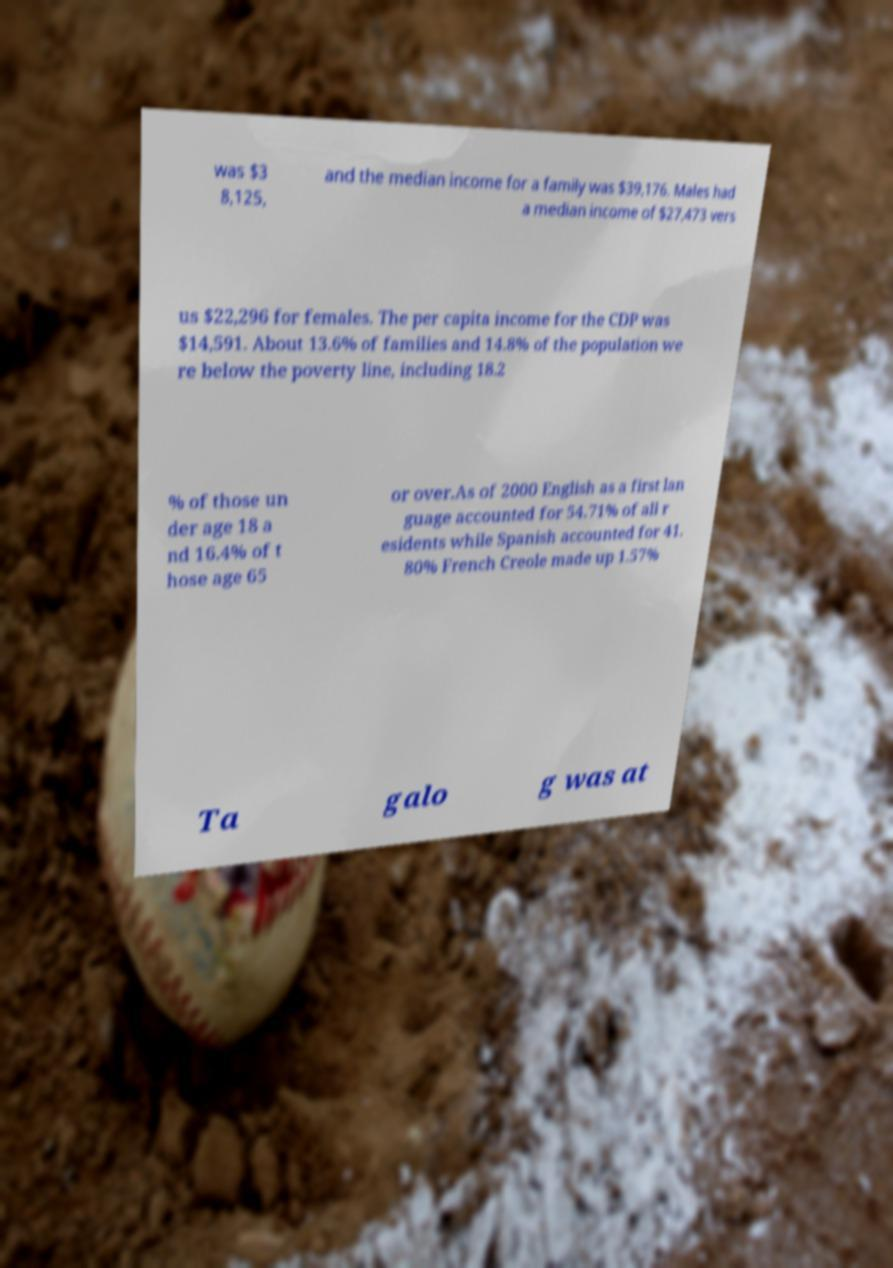I need the written content from this picture converted into text. Can you do that? was $3 8,125, and the median income for a family was $39,176. Males had a median income of $27,473 vers us $22,296 for females. The per capita income for the CDP was $14,591. About 13.6% of families and 14.8% of the population we re below the poverty line, including 18.2 % of those un der age 18 a nd 16.4% of t hose age 65 or over.As of 2000 English as a first lan guage accounted for 54.71% of all r esidents while Spanish accounted for 41. 80% French Creole made up 1.57% Ta galo g was at 